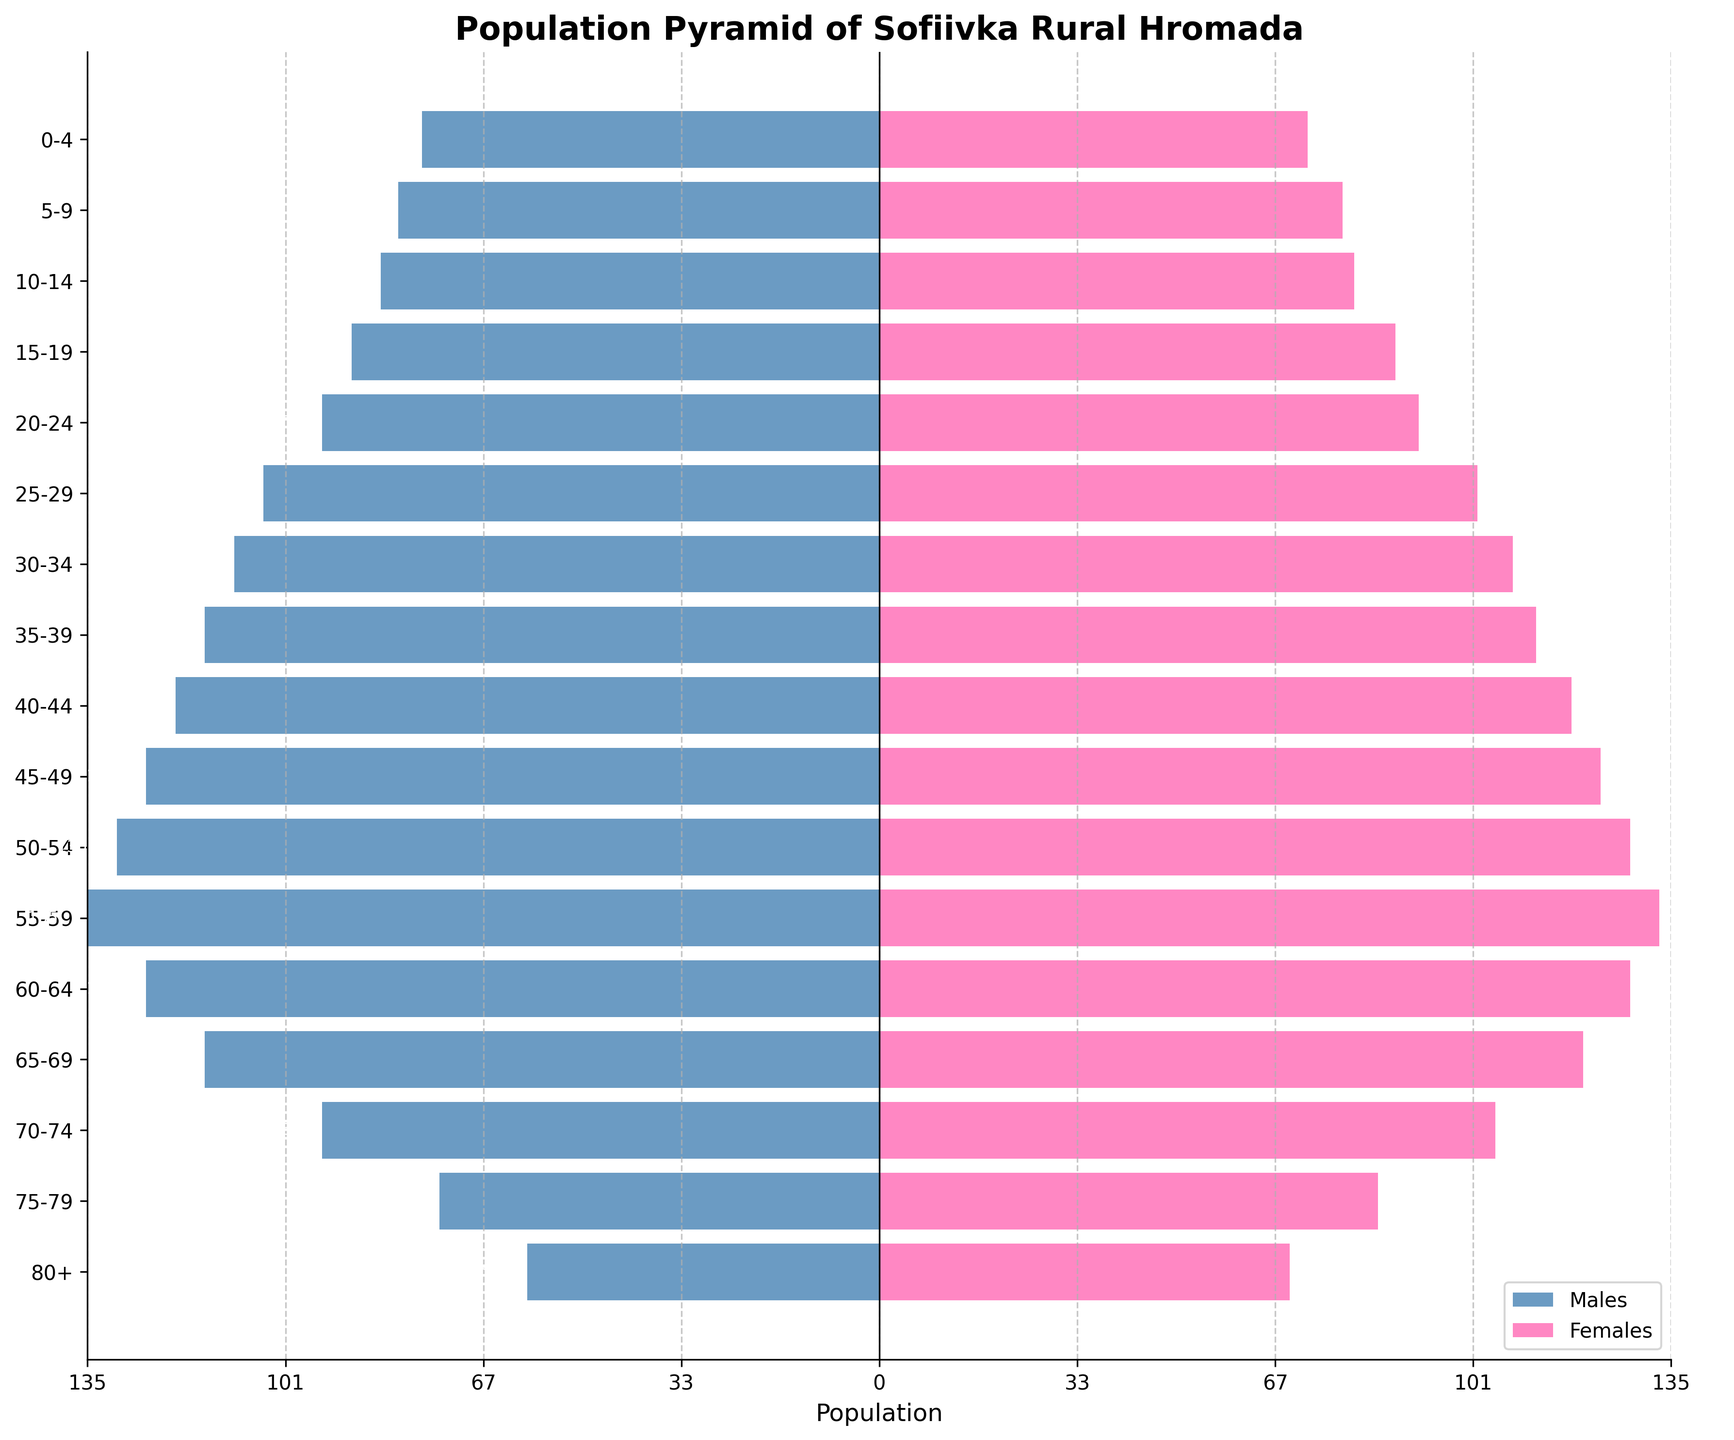What is the title of the plot? The title of the plot is displayed at the top in a bold font. It reads "Population Pyramid of Sofiivka Rural Hromada".
Answer: Population Pyramid of Sofiivka Rural Hromada How many age groups are represented in the plot? Each horizontal bar represents an age group. Counting them from 0-4 to 80+, there are 17 age groups.
Answer: 17 Which age group has the highest number of males? Look at the length of the bars on the left side of the pyramid and find the one that extends the furthest to the left. The 55-59 age group has the longest bar for males, indicating 135 males.
Answer: 55-59 Which age group has the highest number of females? Look at the length of the bars on the right side of the pyramid and find the one that extends the furthest to the right. The 55-59 age group has the longest bar for females, indicating 133 females.
Answer: 55-59 How does the population of males in the 25-29 age group compare to the 0-4 age group? The bar for males in the 25-29 age group is longer than the bar for males in the 0-4 age group. Specifically, there are 105 males in the 25-29 age group and 78 males in the 0-4 age group.
Answer: 25-29 age group has more males Which age group has the most balanced (nearly equal) number of males and females? Examine each age group's bars to see where the length difference between males and females is smallest. The 60-64 age group has 125 males and 128 females, showing a nearly balanced population.
Answer: 60-64 Are there more males or females in the age group 70-74? Compare the lengths of the bars for males and females in the 70-74 age group. There are more females (105) compared to males (95).
Answer: Females What is the total population of the 15-19 age group? Add the number of males and females in the 15-19 age group: 90 males + 88 females = 178 total.
Answer: 178 Which segment of the population is larger, those aged under 20 or those aged 60 and over? Sum the populations for age groups under 20 and 60 and over, then compare them. Under 20: (78+82+85+90+95) + Females (73+79+81+88+92) = 681. Aged 60 and over: Males (125+115+95+75+60) + Females (128+120+105+85+70) = 978. Thus, the population aged 60 and over is larger.
Answer: Those aged 60 and over What is the gender ratio in the 80+ age group? Divide the number of males by the number of females in the 80+ age group to find the ratio. There are 60 males and 70 females, so the ratio is 60/70 = 0.86.
Answer: 0.86 